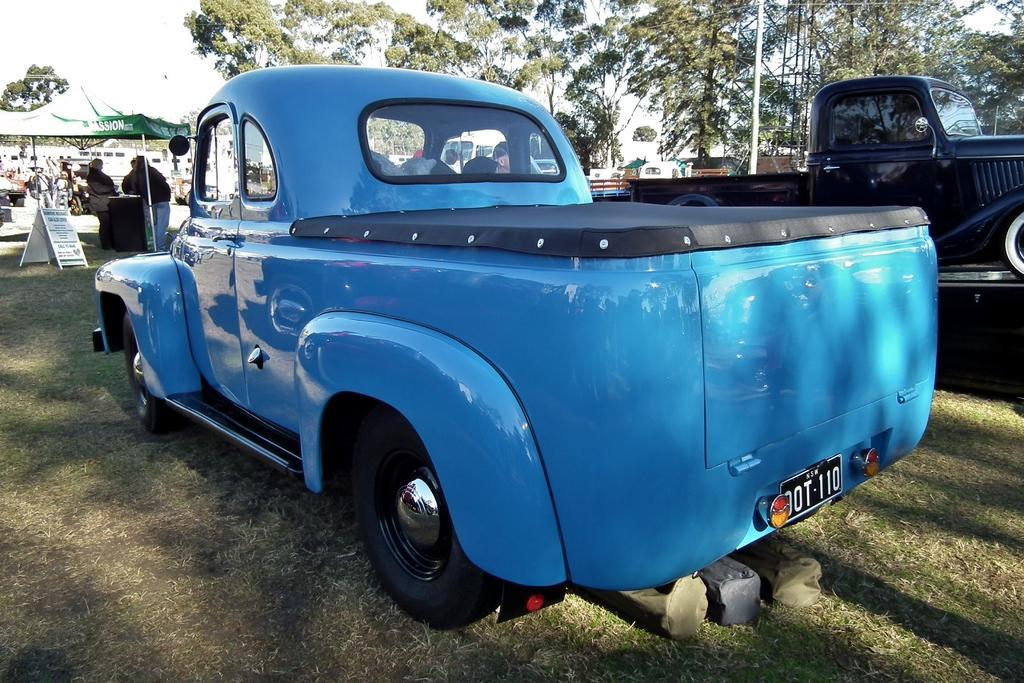How would you summarize this image in a sentence or two? In this image there are two vintage cars parked on the ground one beside the other. On the left side there is a tent under which there are few people. On the right side there are trees in the background. 